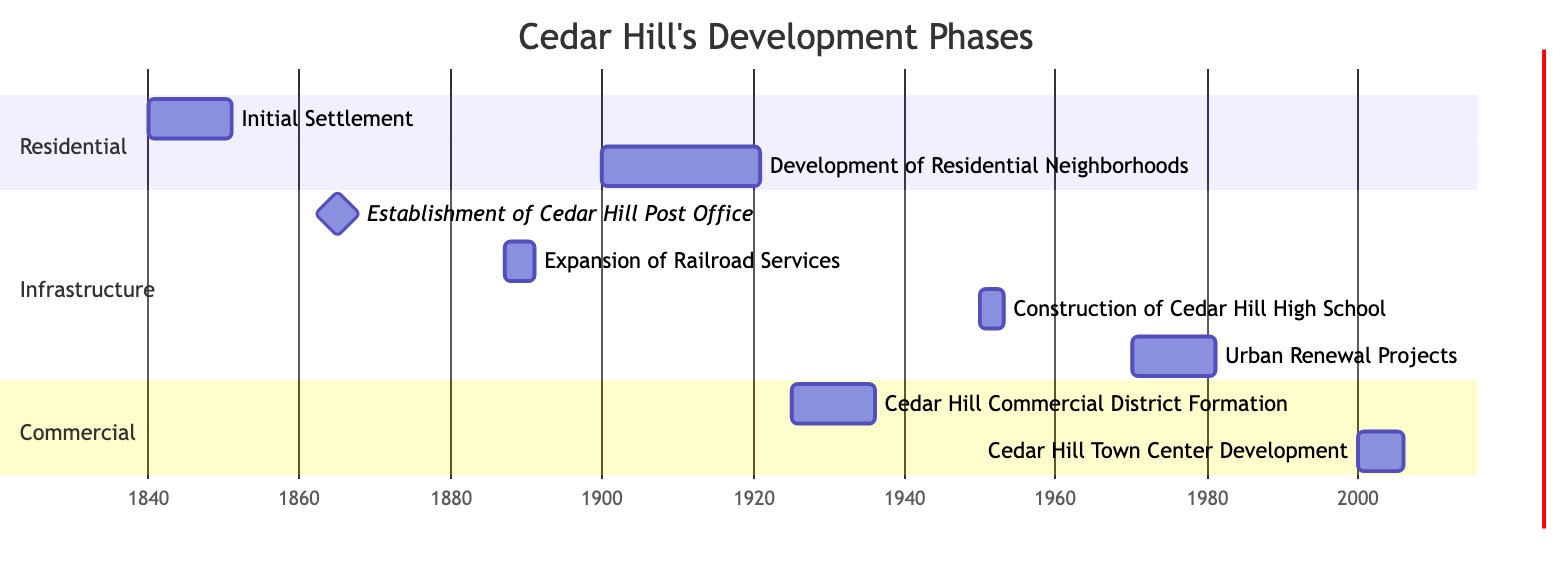What are the categories represented in the Gantt chart? The Gantt chart includes three distinct categories: Residential, Infrastructure, and Commercial, each representing different aspects of Cedar Hill's development phases.
Answer: Residential, Infrastructure, Commercial How many phases are categorized under Infrastructure? In the Gantt chart, there are four phases categorized under Infrastructure: Establishment of Cedar Hill Post Office, Expansion of Railroad Services, Construction of Cedar Hill High School, and Urban Renewal Projects.
Answer: 4 When was the Cedar Hill High School construction phase? According to the Gantt chart, the construction phase for Cedar Hill High School started on January 1, 1950, and ended on December 31, 1952.
Answer: 1950-1952 Which phase marks the beginning of Cedar Hill's Urban Renewal Projects? The Urban Renewal Projects phase begins on January 1, 1970, as indicated in the Gantt chart. This date marks the start of new initiatives aimed at revitalizing Cedar Hill.
Answer: 1970 What is the duration of the Cedar Hill Commercial District Formation phase? The duration of the Cedar Hill Commercial District Formation phase spans from January 1, 1925, to December 31, 1935, resulting in a total period of 11 years.
Answer: 11 years Which infrastructure project occurred immediately after the Initial Settlement phase? The Establishment of Cedar Hill Post Office occurred immediately after the Initial Settlement phase, as indicated in the Gantt chart with a start date of January 1, 1865.
Answer: Establishment of Cedar Hill Post Office How many years did the Development of Residential Neighborhoods last? The Development of Residential Neighborhoods lasted for 21 years, from January 1, 1900, to December 31, 1920, which is calculated by subtracting the start year from the end year.
Answer: 21 years Which category does the Cedar Hill Town Center Development phase belong to? The Cedar Hill Town Center Development phase belongs to the Commercial category, as specified in the Gantt chart, indicating its focus on commercial growth within the city.
Answer: Commercial What is the latest phase in the timeline for Cedar Hill's development? The latest phase in the timeline is the Cedar Hill Town Center Development, which lasted from January 1, 2000, to December 31, 2005, marking recent growth initiatives in Cedar Hill.
Answer: Cedar Hill Town Center Development 